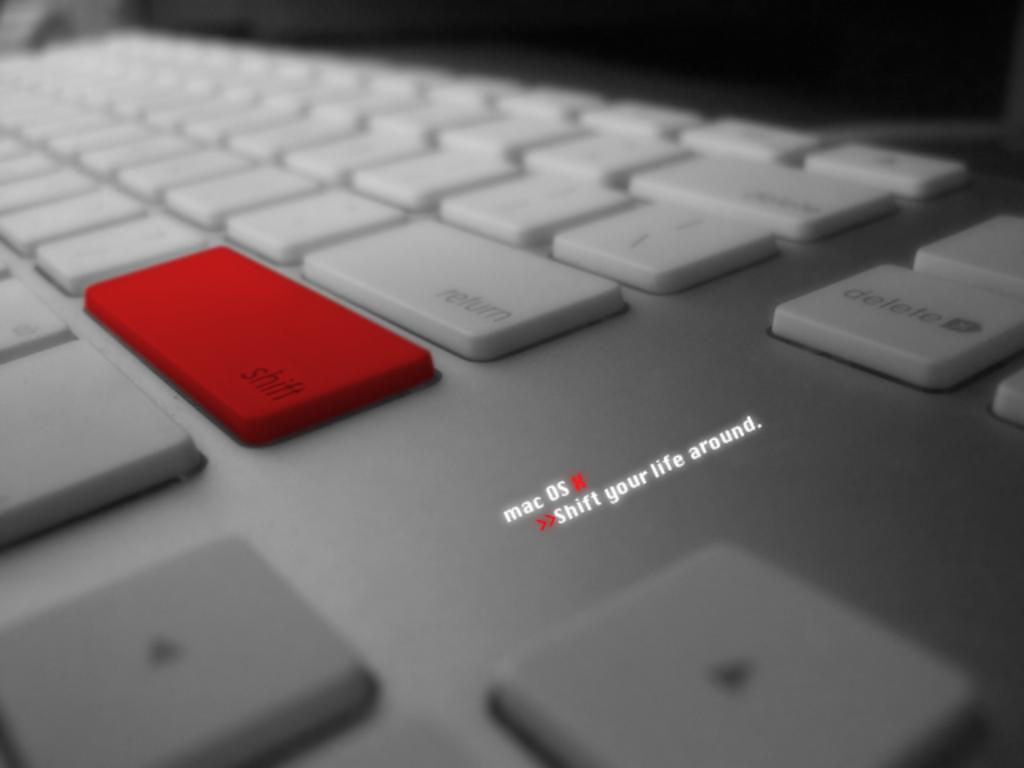What is the motto for this product?
Offer a very short reply. Shift your life around. Which keyboard key is this motto referring to?
Keep it short and to the point. Shift. 